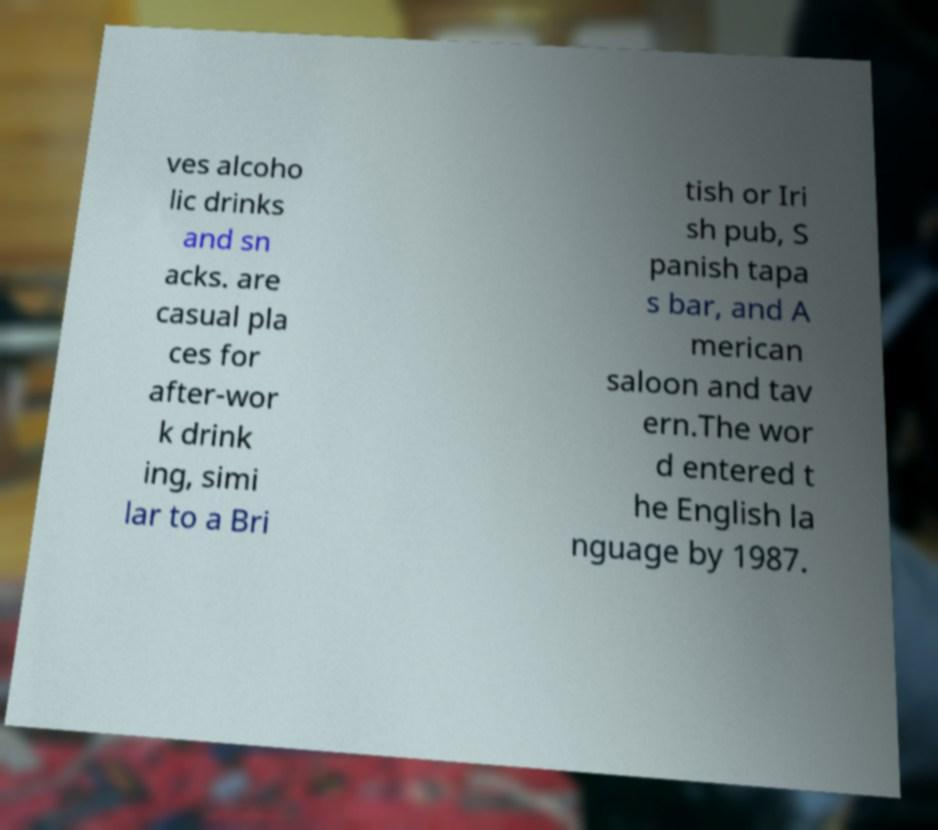Please read and relay the text visible in this image. What does it say? ves alcoho lic drinks and sn acks. are casual pla ces for after-wor k drink ing, simi lar to a Bri tish or Iri sh pub, S panish tapa s bar, and A merican saloon and tav ern.The wor d entered t he English la nguage by 1987. 